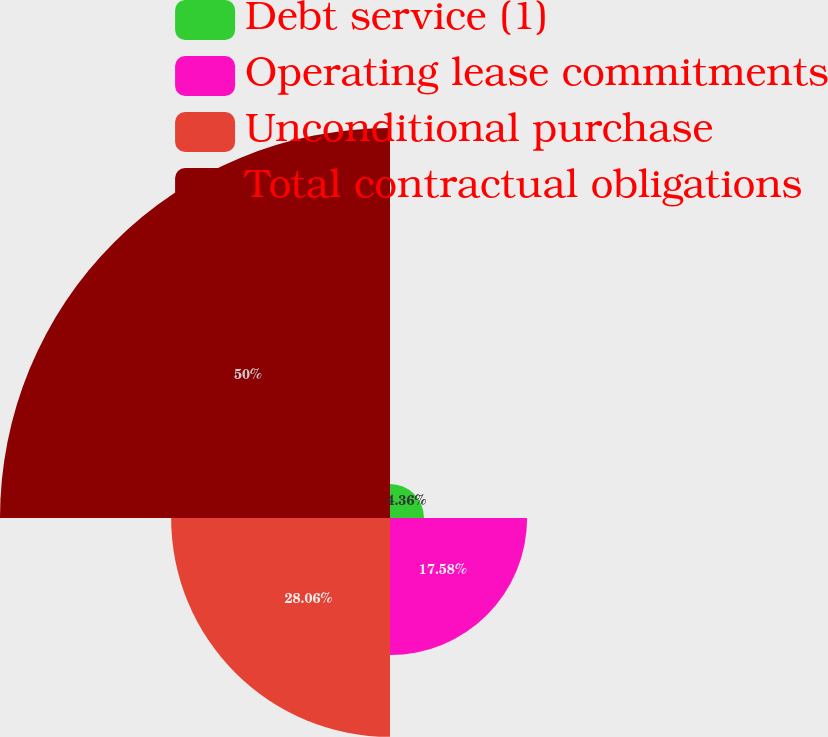Convert chart to OTSL. <chart><loc_0><loc_0><loc_500><loc_500><pie_chart><fcel>Debt service (1)<fcel>Operating lease commitments<fcel>Unconditional purchase<fcel>Total contractual obligations<nl><fcel>4.36%<fcel>17.58%<fcel>28.06%<fcel>50.0%<nl></chart> 